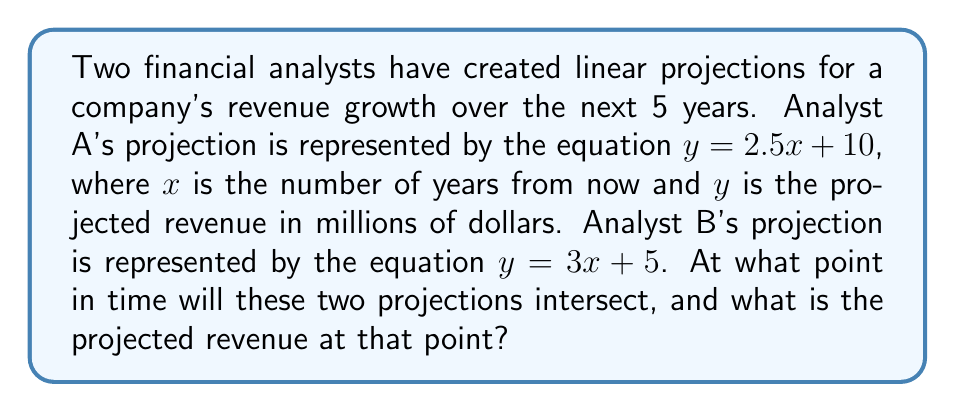Can you solve this math problem? To find the intersection point of these two financial projections, we need to solve the system of linear equations:

$$\begin{cases}
y = 2.5x + 10 \\
y = 3x + 5
\end{cases}$$

Step 1: Set the equations equal to each other since they intersect at a point where $y$ is the same for both equations.
$2.5x + 10 = 3x + 5$

Step 2: Subtract $2.5x$ from both sides.
$10 = 0.5x + 5$

Step 3: Subtract 5 from both sides.
$5 = 0.5x$

Step 4: Multiply both sides by 2 to isolate $x$.
$10 = x$

Step 5: Now that we know the $x$-coordinate of the intersection point, we can substitute it into either of the original equations to find the $y$-coordinate. Let's use Analyst A's equation:

$y = 2.5(10) + 10$
$y = 25 + 10 = 35$

Therefore, the projections intersect at the point $(10, 35)$.

Interpretation: The two projections will intersect 10 years from now, with a projected revenue of $35 million at that time.
Answer: The two financial projections will intersect at the point $(10, 35)$, meaning they will converge 10 years from now with a projected revenue of $35 million. 